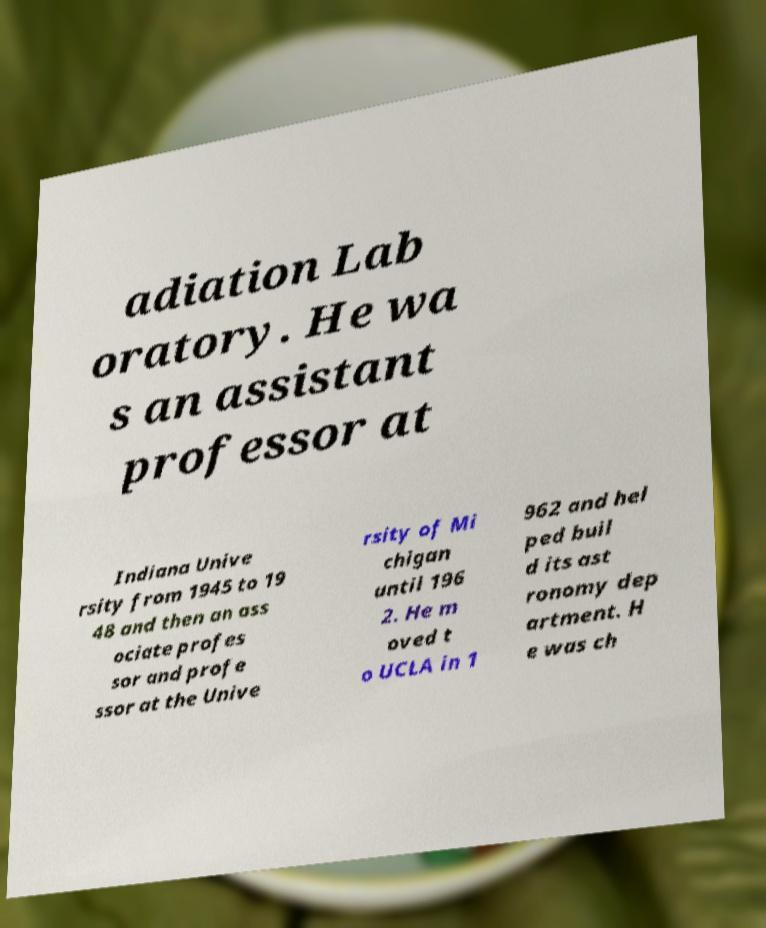There's text embedded in this image that I need extracted. Can you transcribe it verbatim? adiation Lab oratory. He wa s an assistant professor at Indiana Unive rsity from 1945 to 19 48 and then an ass ociate profes sor and profe ssor at the Unive rsity of Mi chigan until 196 2. He m oved t o UCLA in 1 962 and hel ped buil d its ast ronomy dep artment. H e was ch 